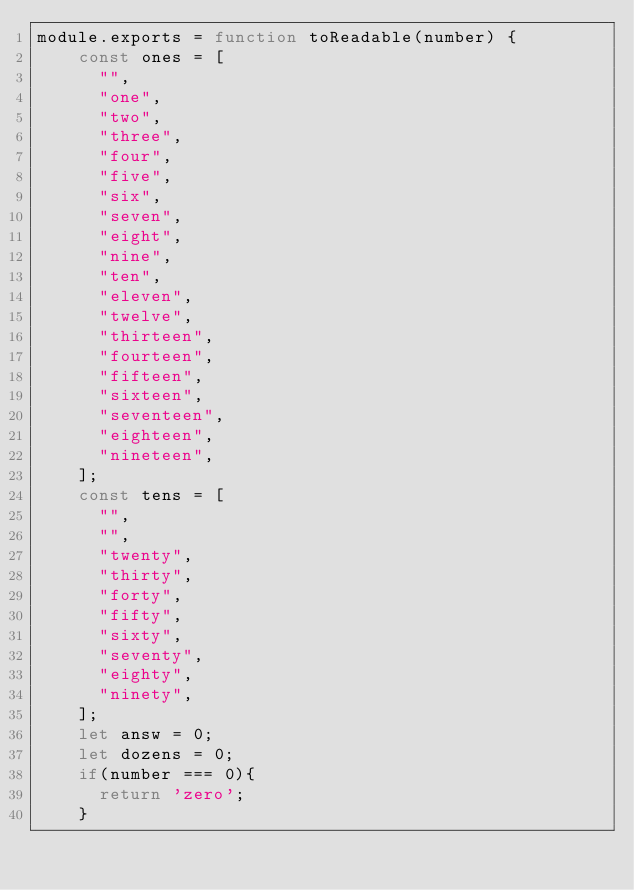Convert code to text. <code><loc_0><loc_0><loc_500><loc_500><_JavaScript_>module.exports = function toReadable(number) {
    const ones = [
      "",
      "one",
      "two",
      "three",
      "four",
      "five",
      "six",
      "seven",
      "eight",
      "nine",
      "ten",
      "eleven",
      "twelve",
      "thirteen",
      "fourteen",
      "fifteen",
      "sixteen",
      "seventeen",
      "eighteen",
      "nineteen",
    ];
    const tens = [
      "",
      "",
      "twenty",
      "thirty",
      "forty",
      "fifty",
      "sixty",
      "seventy",
      "eighty",
      "ninety",
    ];
    let answ = 0;
    let dozens = 0;
    if(number === 0){
      return 'zero';
    }</code> 